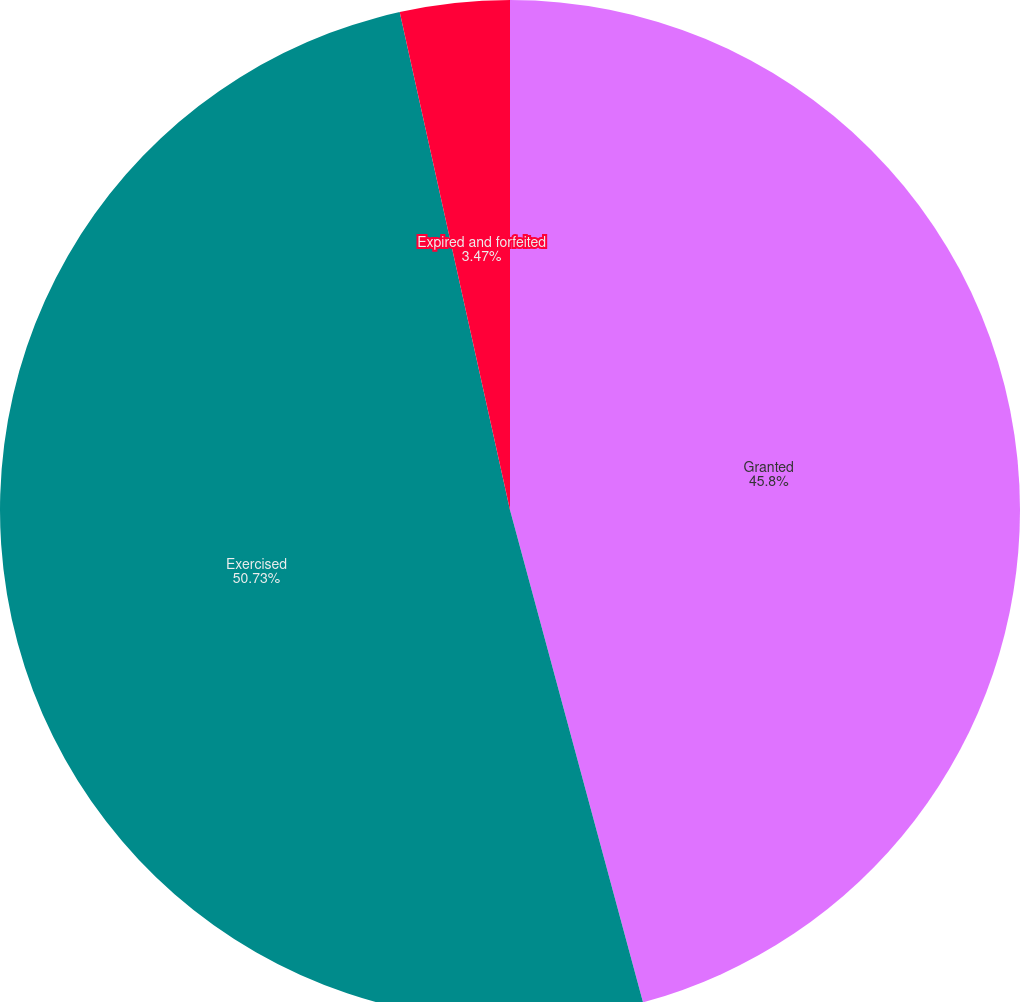Convert chart to OTSL. <chart><loc_0><loc_0><loc_500><loc_500><pie_chart><fcel>Granted<fcel>Exercised<fcel>Expired and forfeited<nl><fcel>45.8%<fcel>50.73%<fcel>3.47%<nl></chart> 